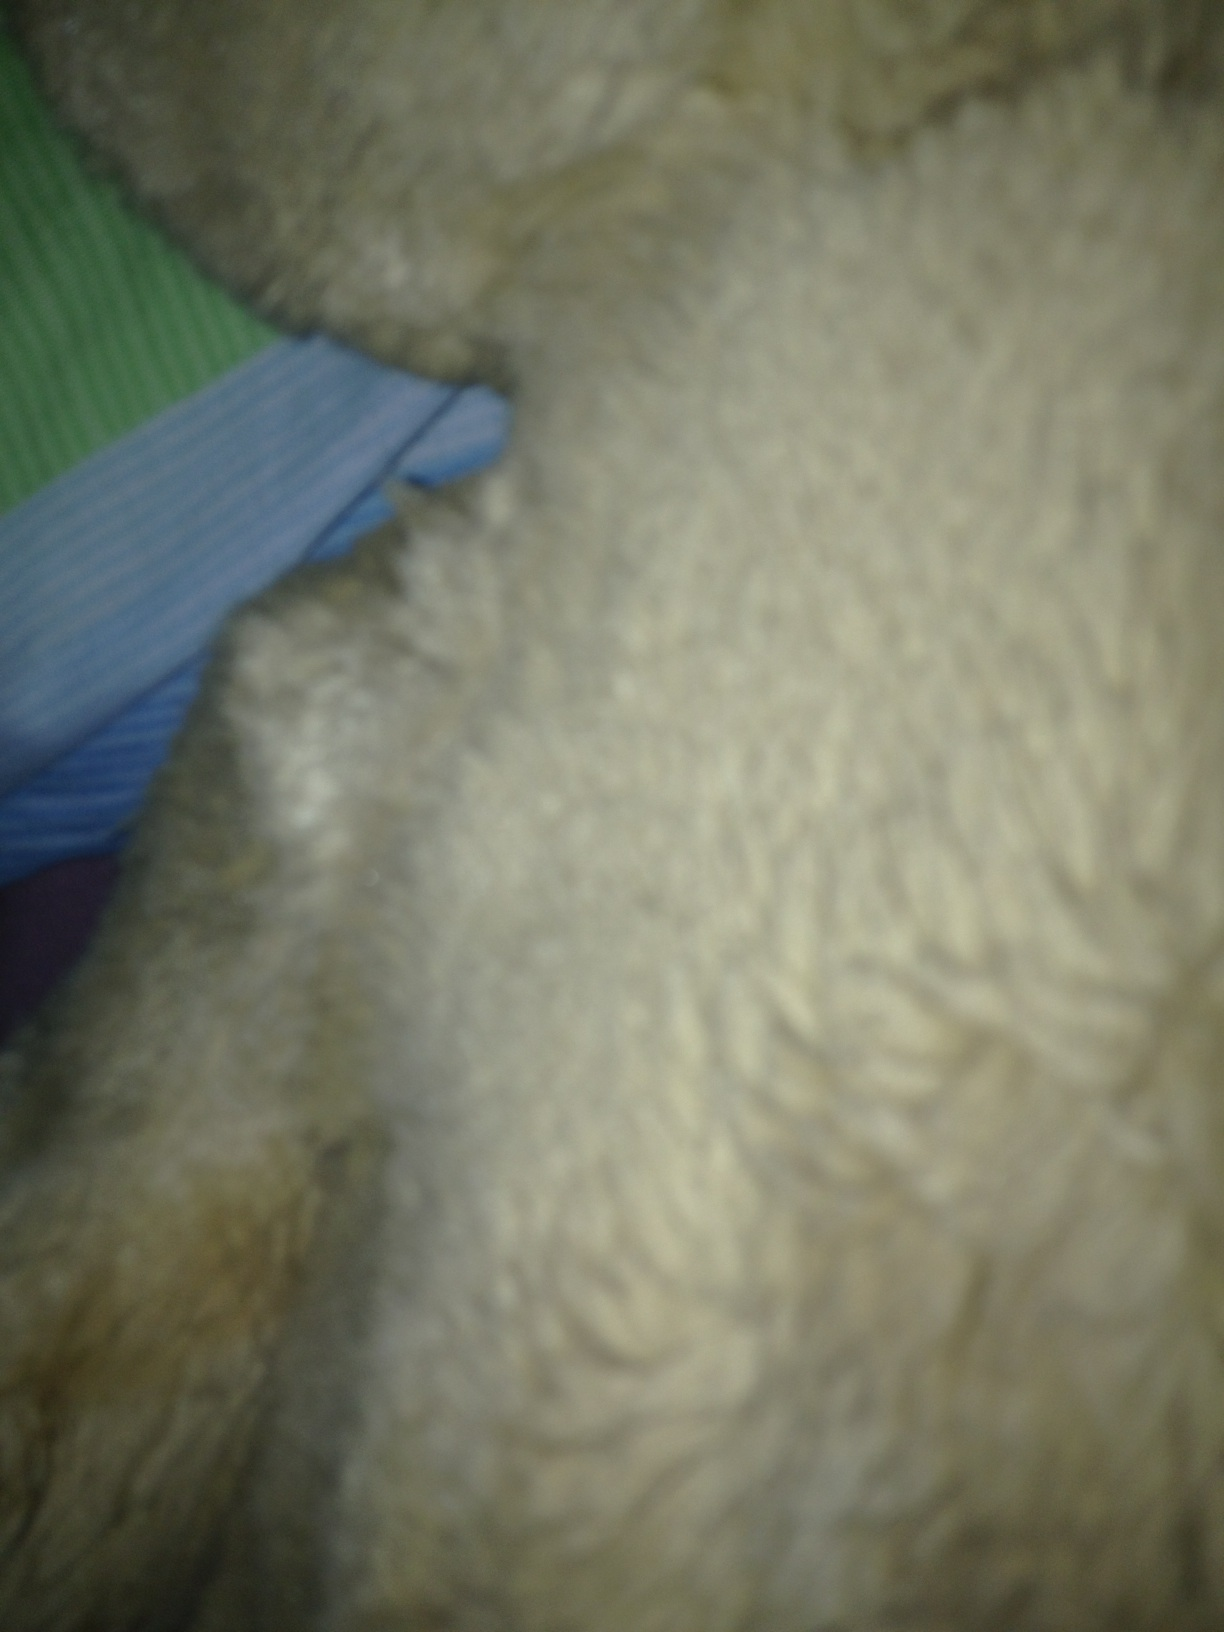Can you describe this image in detail? This image features a close-up view of a soft, furry texture. The texture seems to be fluffy and plush, with individual strands of fur visible. It looks like it could be part of a stuffed animal or a plush blanket. In the background, there are hints of colored fabric, possibly bedding, with shades of green and blue, adding a contrast to the main subject. What could this object be? This object looks like it could be a part of a stuffed toy, perhaps a teddy bear or another plush animal, given the furry texture. Alternatively, it might be a section of a fluffy blanket or a piece of soft clothing. 